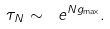<formula> <loc_0><loc_0><loc_500><loc_500>\tau _ { N } \sim \ e ^ { N g _ { \max } } .</formula> 